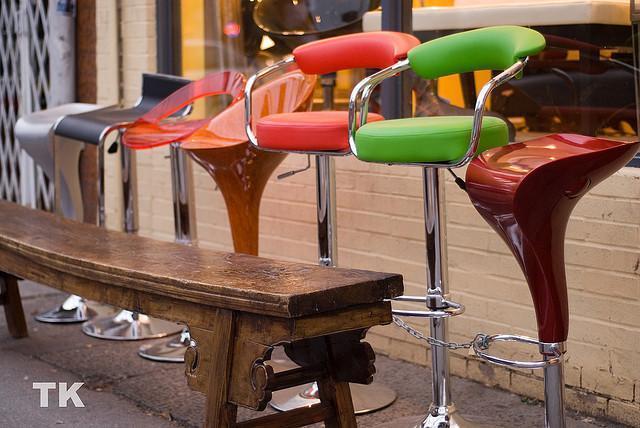How many stools are there?
Give a very brief answer. 8. How many chairs are in the photo?
Give a very brief answer. 7. How many people have an umbrella?
Give a very brief answer. 0. 